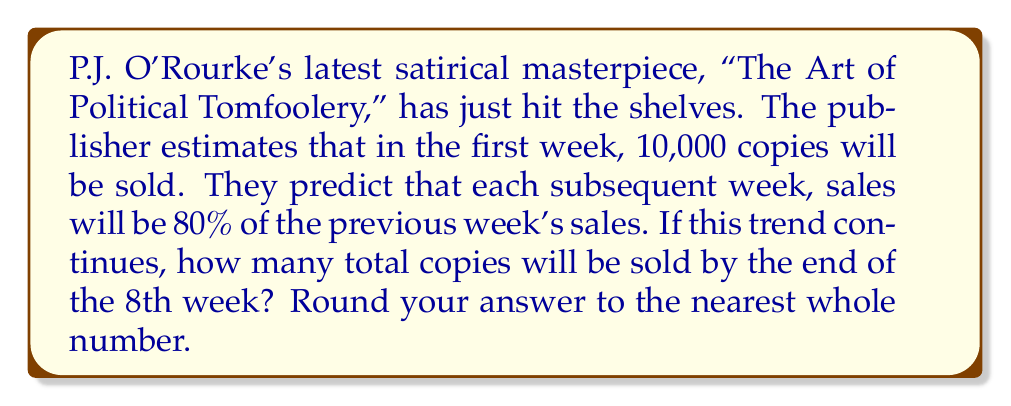Solve this math problem. Let's approach this with the wit and precision that would make P.J. O'Rourke proud:

1) First, we recognize this as a geometric series. The initial term $a = 10,000$ and the common ratio $r = 0.8$.

2) The series looks like this:
   $10,000 + 10,000(0.8) + 10,000(0.8)^2 + ... + 10,000(0.8)^7$

3) The formula for the sum of a geometric series is:
   $$S_n = \frac{a(1-r^n)}{1-r}$$
   Where $a$ is the first term, $r$ is the common ratio, and $n$ is the number of terms.

4) In our case:
   $a = 10,000$
   $r = 0.8$
   $n = 8$ (8 weeks)

5) Plugging these into our formula:
   $$S_8 = \frac{10,000(1-0.8^8)}{1-0.8}$$

6) Let's calculate this step by step:
   $$S_8 = \frac{10,000(1-0.16777216)}{0.2}$$
   $$S_8 = \frac{10,000(0.83222784)}{0.2}$$
   $$S_8 = \frac{8322.2784}{0.2}$$
   $$S_8 = 41611.392$$

7) Rounding to the nearest whole number:
   $S_8 \approx 41,611$

Thus, by the end of the 8th week, approximately 41,611 copies of "The Art of Political Tomfoolery" will have been sold, assuming the sales trend holds. O'Rourke might quip that's enough readers to start a small, satirically-inclined nation.
Answer: 41,611 copies 